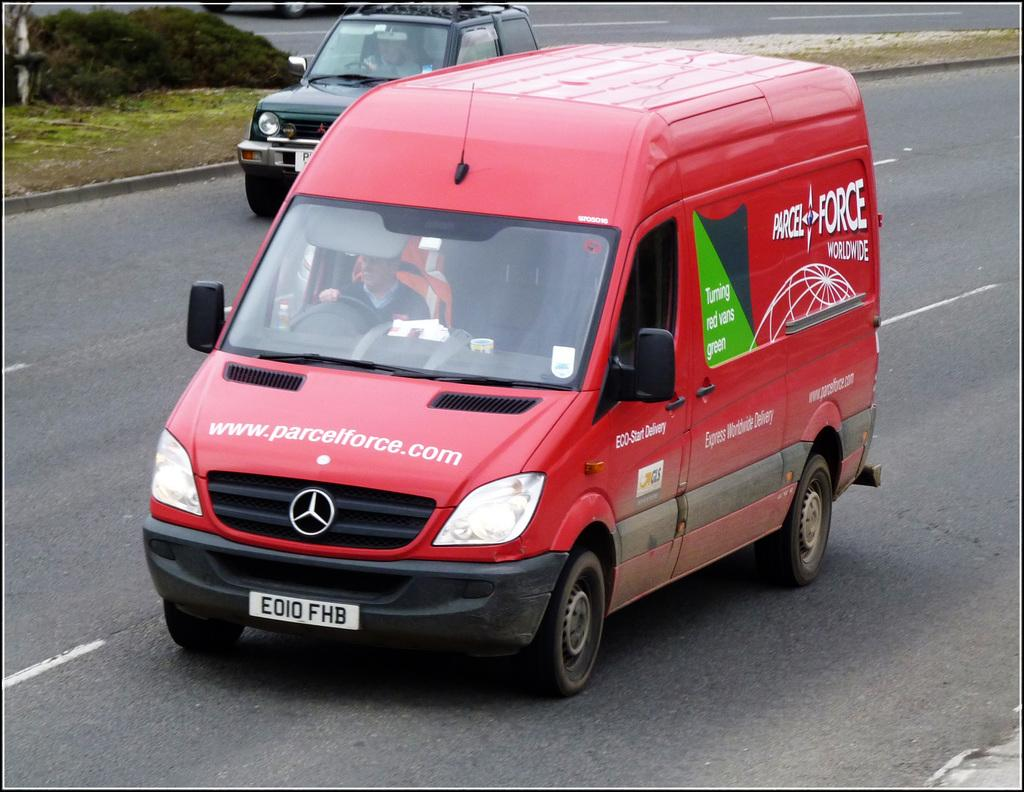<image>
Describe the image concisely. A red van with the website www.parcelforce.com written on it. 